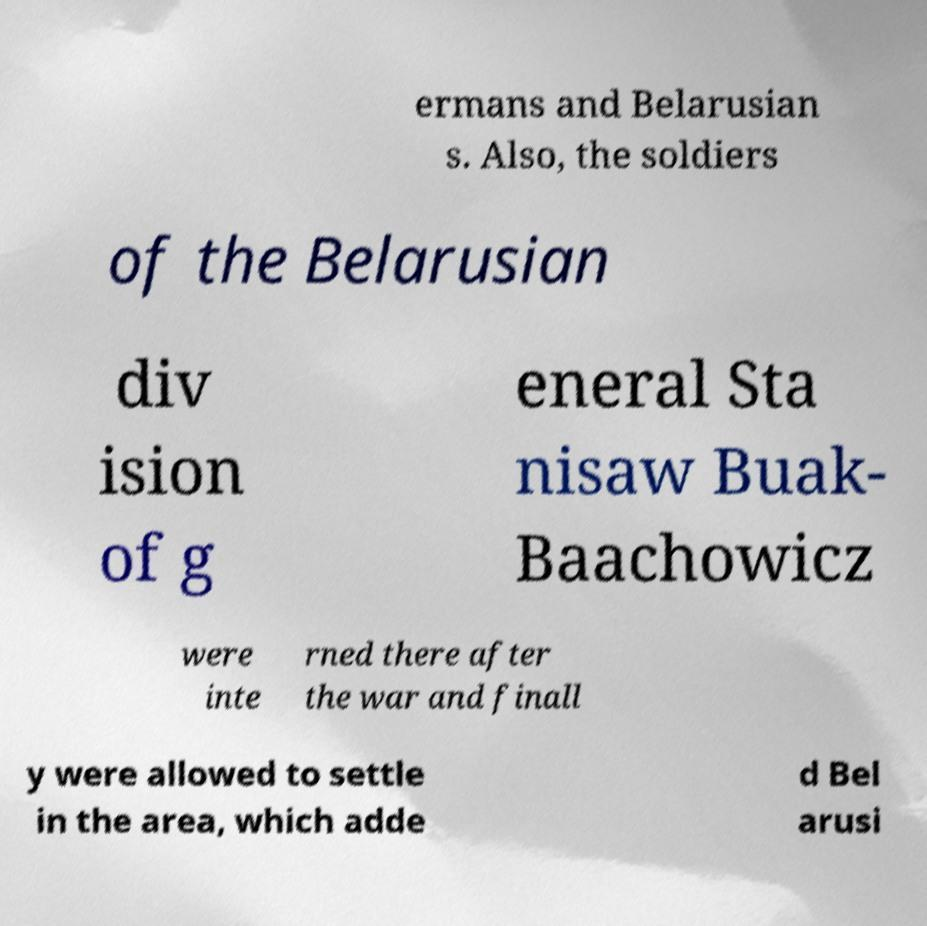Can you accurately transcribe the text from the provided image for me? ermans and Belarusian s. Also, the soldiers of the Belarusian div ision of g eneral Sta nisaw Buak- Baachowicz were inte rned there after the war and finall y were allowed to settle in the area, which adde d Bel arusi 